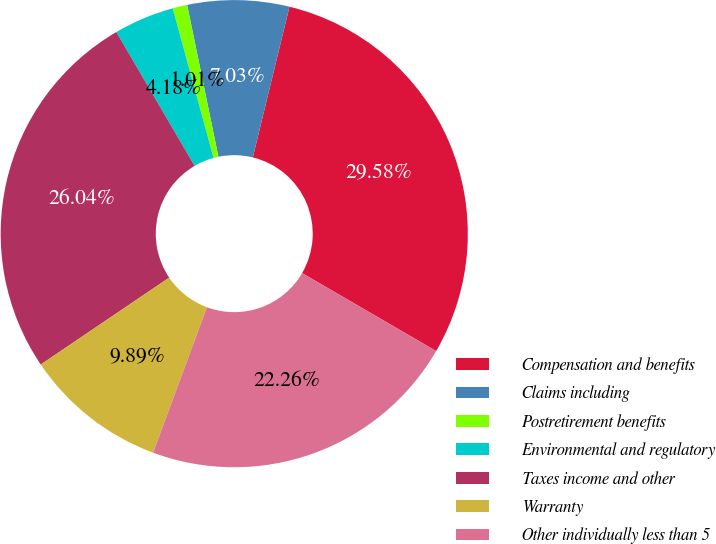<chart> <loc_0><loc_0><loc_500><loc_500><pie_chart><fcel>Compensation and benefits<fcel>Claims including<fcel>Postretirement benefits<fcel>Environmental and regulatory<fcel>Taxes income and other<fcel>Warranty<fcel>Other individually less than 5<nl><fcel>29.58%<fcel>7.03%<fcel>1.01%<fcel>4.18%<fcel>26.04%<fcel>9.89%<fcel>22.26%<nl></chart> 